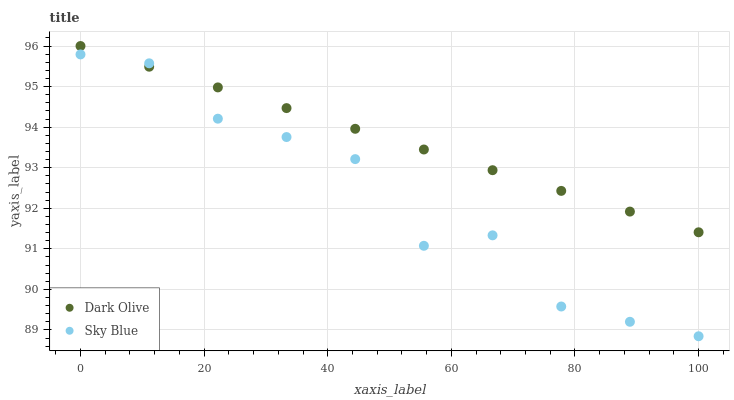Does Sky Blue have the minimum area under the curve?
Answer yes or no. Yes. Does Dark Olive have the maximum area under the curve?
Answer yes or no. Yes. Does Dark Olive have the minimum area under the curve?
Answer yes or no. No. Is Dark Olive the smoothest?
Answer yes or no. Yes. Is Sky Blue the roughest?
Answer yes or no. Yes. Is Dark Olive the roughest?
Answer yes or no. No. Does Sky Blue have the lowest value?
Answer yes or no. Yes. Does Dark Olive have the lowest value?
Answer yes or no. No. Does Dark Olive have the highest value?
Answer yes or no. Yes. Does Sky Blue intersect Dark Olive?
Answer yes or no. Yes. Is Sky Blue less than Dark Olive?
Answer yes or no. No. Is Sky Blue greater than Dark Olive?
Answer yes or no. No. 